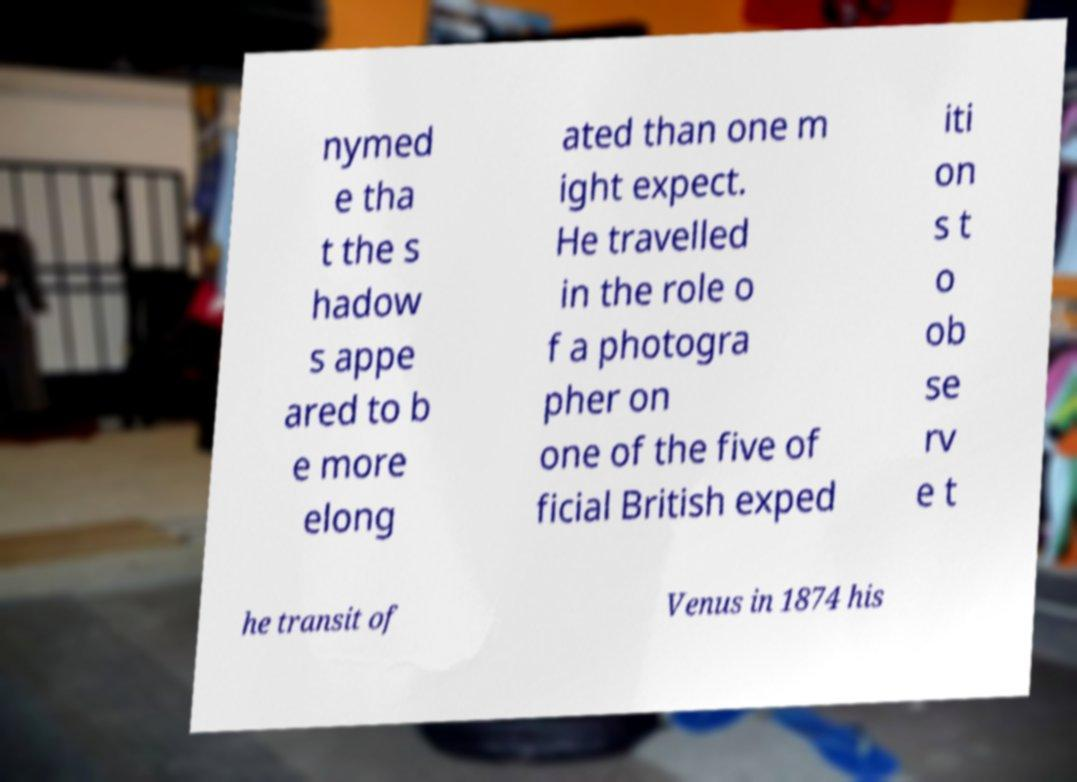What messages or text are displayed in this image? I need them in a readable, typed format. nymed e tha t the s hadow s appe ared to b e more elong ated than one m ight expect. He travelled in the role o f a photogra pher on one of the five of ficial British exped iti on s t o ob se rv e t he transit of Venus in 1874 his 